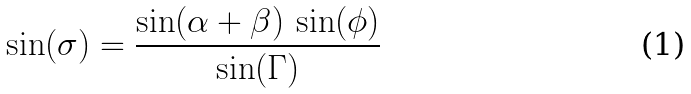<formula> <loc_0><loc_0><loc_500><loc_500>\sin ( \sigma ) = \frac { \sin ( \alpha + \beta ) \, \sin ( \phi ) } { \sin ( \Gamma ) }</formula> 